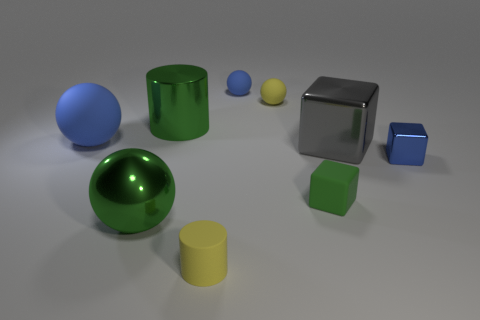How does the size of the blue sphere compare with the other objects? The blue sphere is one of the larger objects within the scene. It is significantly larger than the smaller yellow sphere, green cube, and yellow cylinder. However, it is comparable in size to the green sphere, and smaller than the large, metallic-looking cube. In terms of visual weight, how do the objects contribute to the overall composition? Visually, the metallic cube is quite dominant because of its size and reflective surface, giving it a heavy visual weight. The green and blue spheres also draw the eye due to their size and central positioning. The smaller objects, despite their bright colors, hold less visual weight as they are overshadowed by the larger elements. 